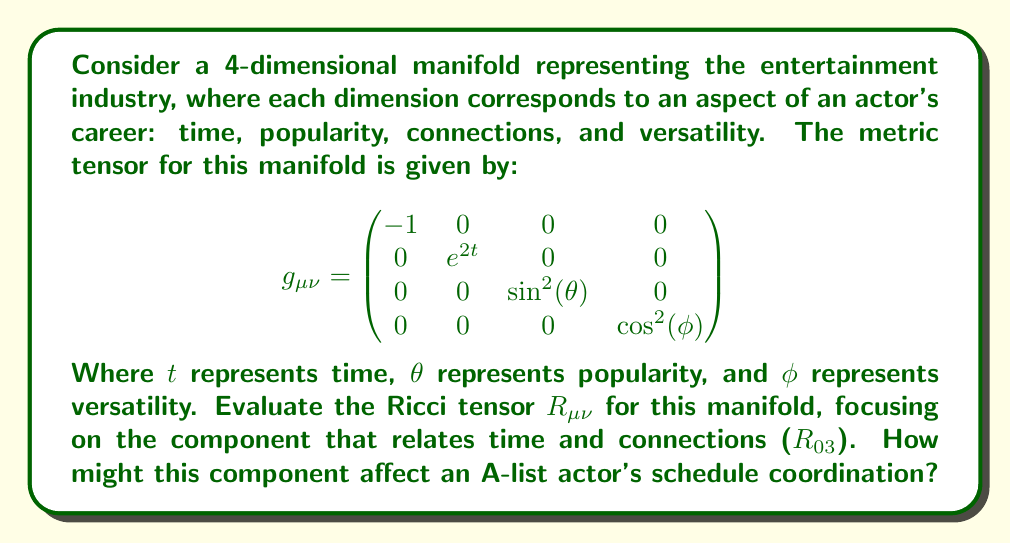Help me with this question. To evaluate the Ricci tensor, we need to follow these steps:

1) First, calculate the Christoffel symbols using the formula:
   $$\Gamma^\lambda_{\mu\nu} = \frac{1}{2}g^{\lambda\sigma}(\partial_\mu g_{\nu\sigma} + \partial_\nu g_{\mu\sigma} - \partial_\sigma g_{\mu\nu})$$

2) Then, use the Christoffel symbols to compute the Riemann curvature tensor:
   $$R^\rho_{\sigma\mu\nu} = \partial_\mu \Gamma^\rho_{\nu\sigma} - \partial_\nu \Gamma^\rho_{\mu\sigma} + \Gamma^\rho_{\mu\lambda}\Gamma^\lambda_{\nu\sigma} - \Gamma^\rho_{\nu\lambda}\Gamma^\lambda_{\mu\sigma}$$

3) Finally, contract the Riemann tensor to get the Ricci tensor:
   $$R_{\mu\nu} = R^\lambda_{\mu\lambda\nu}$$

For the given metric, most of the Christoffel symbols will be zero due to the diagonal nature of the metric. The non-zero components are:

$$\Gamma^1_{11} = 1, \Gamma^2_{22} = -\sin\theta\cos\theta, \Gamma^3_{33} = -\sin\phi\cos\phi$$

Using these, we can compute the Riemann tensor components. For $R_{03}$, we need $R^{\lambda}_{0\lambda 3}$. However, all these components are zero because:

- $\partial_0 \Gamma^\lambda_{3\sigma} = 0$ (no time dependence in Christoffel symbols)
- $\partial_3 \Gamma^\lambda_{0\sigma} = 0$ (Christoffel symbols with 0 index are all zero)
- $\Gamma^\lambda_{0\mu} = 0$ for all $\lambda, \mu$

Therefore, $R_{03} = 0$.

This result indicates that there is no direct curvature interaction between the time dimension and the versatility dimension in this model of the entertainment industry.
Answer: $R_{03} = 0$ 